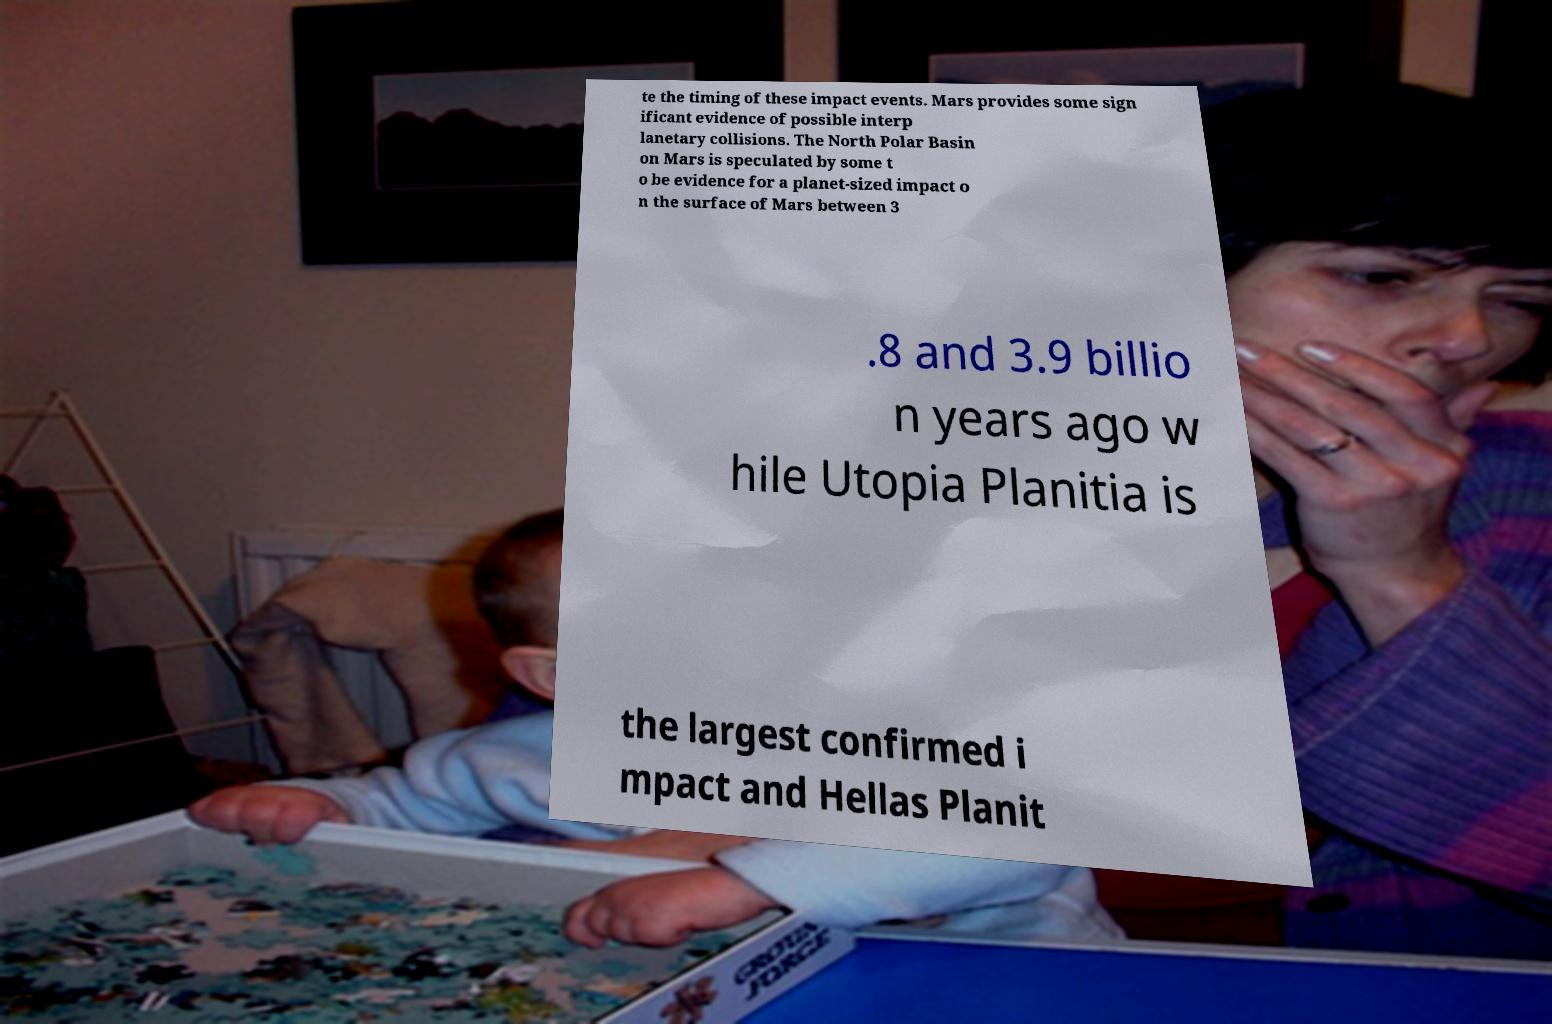Please identify and transcribe the text found in this image. te the timing of these impact events. Mars provides some sign ificant evidence of possible interp lanetary collisions. The North Polar Basin on Mars is speculated by some t o be evidence for a planet-sized impact o n the surface of Mars between 3 .8 and 3.9 billio n years ago w hile Utopia Planitia is the largest confirmed i mpact and Hellas Planit 